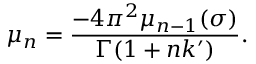<formula> <loc_0><loc_0><loc_500><loc_500>\mu _ { n } = \frac { - 4 \pi ^ { 2 } \mu _ { n - 1 } ( \sigma ) } { \Gamma ( 1 + n k ^ { \prime } ) } .</formula> 